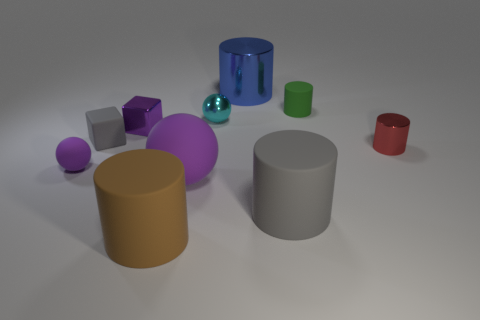Subtract all green cylinders. How many cylinders are left? 4 Subtract all gray matte cylinders. How many cylinders are left? 4 Subtract 1 cylinders. How many cylinders are left? 4 Subtract all cyan cylinders. Subtract all brown blocks. How many cylinders are left? 5 Subtract all cubes. How many objects are left? 8 Add 9 big red rubber blocks. How many big red rubber blocks exist? 9 Subtract 0 gray balls. How many objects are left? 10 Subtract all small rubber balls. Subtract all tiny brown cubes. How many objects are left? 9 Add 3 large purple rubber objects. How many large purple rubber objects are left? 4 